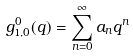Convert formula to latex. <formula><loc_0><loc_0><loc_500><loc_500>g _ { 1 , 0 } ^ { 0 } ( q ) = \sum _ { n = 0 } ^ { \infty } a _ { n } q ^ { n }</formula> 